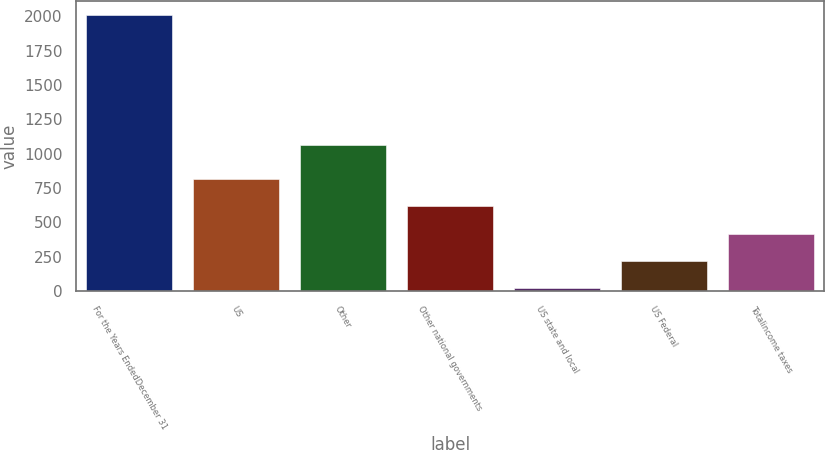Convert chart to OTSL. <chart><loc_0><loc_0><loc_500><loc_500><bar_chart><fcel>For the Years EndedDecember 31<fcel>US<fcel>Other<fcel>Other national governments<fcel>US state and local<fcel>US Federal<fcel>Totalincome taxes<nl><fcel>2010<fcel>816.6<fcel>1065<fcel>617.7<fcel>21<fcel>219.9<fcel>418.8<nl></chart> 